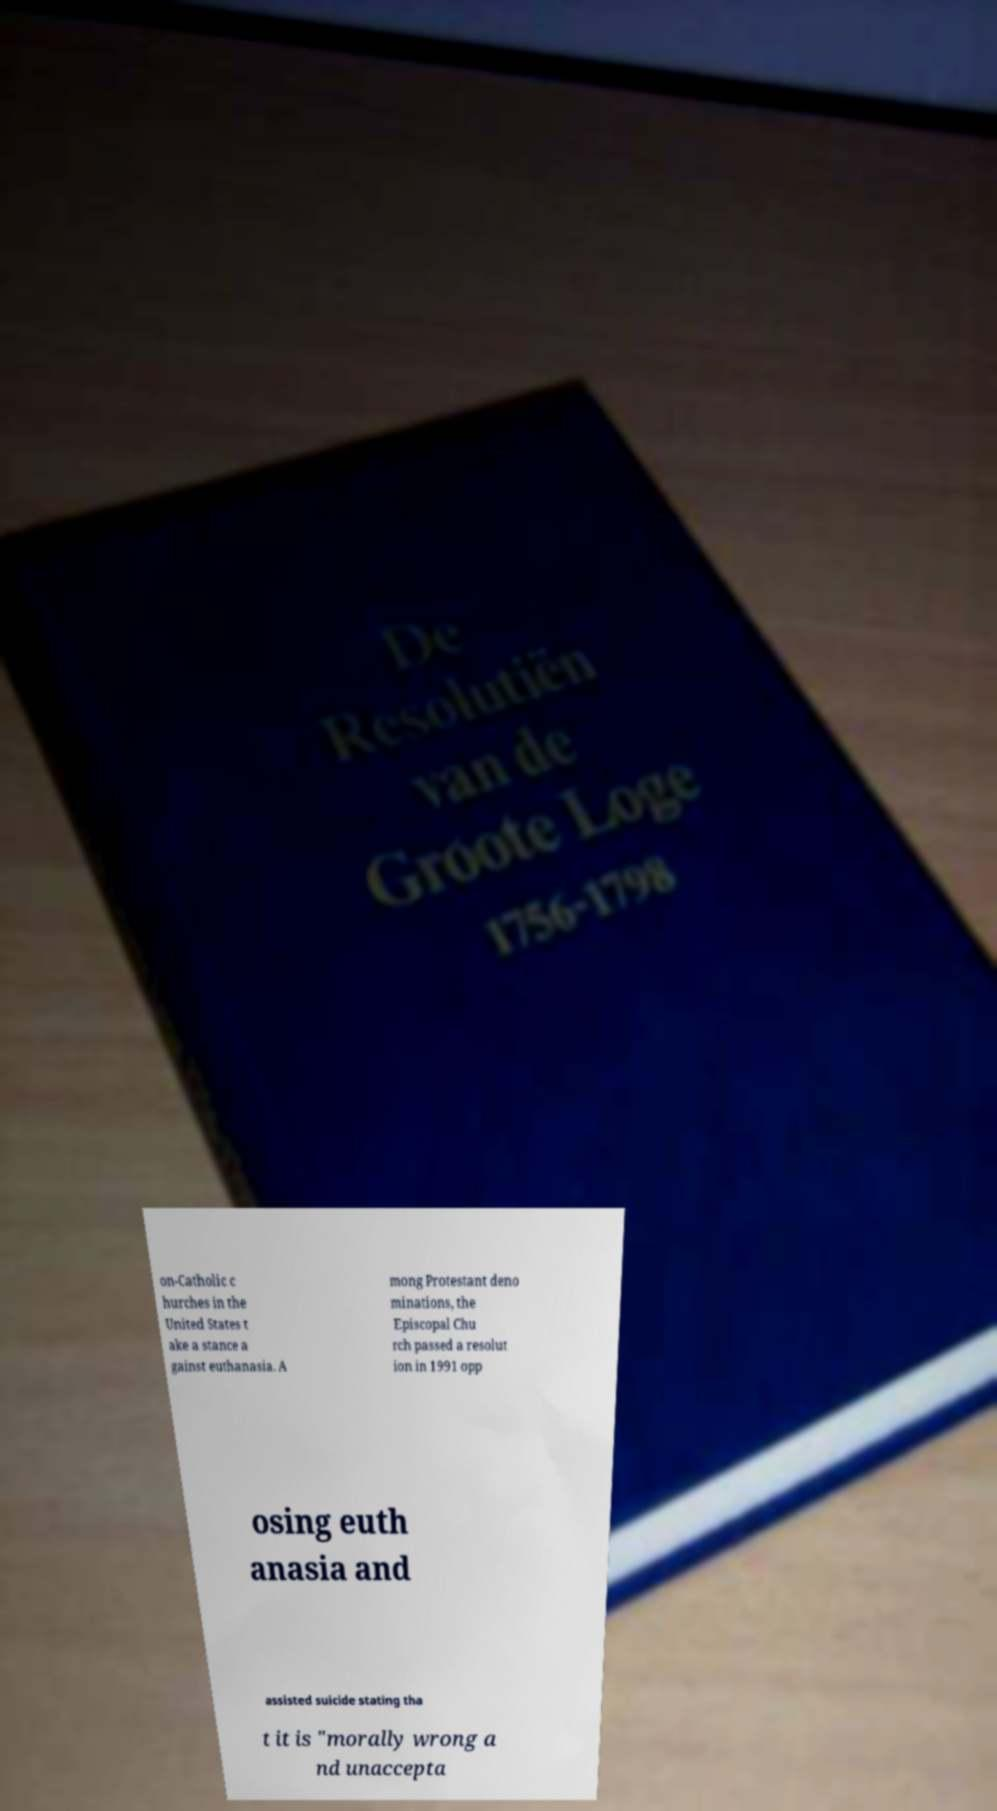For documentation purposes, I need the text within this image transcribed. Could you provide that? on-Catholic c hurches in the United States t ake a stance a gainst euthanasia. A mong Protestant deno minations, the Episcopal Chu rch passed a resolut ion in 1991 opp osing euth anasia and assisted suicide stating tha t it is "morally wrong a nd unaccepta 